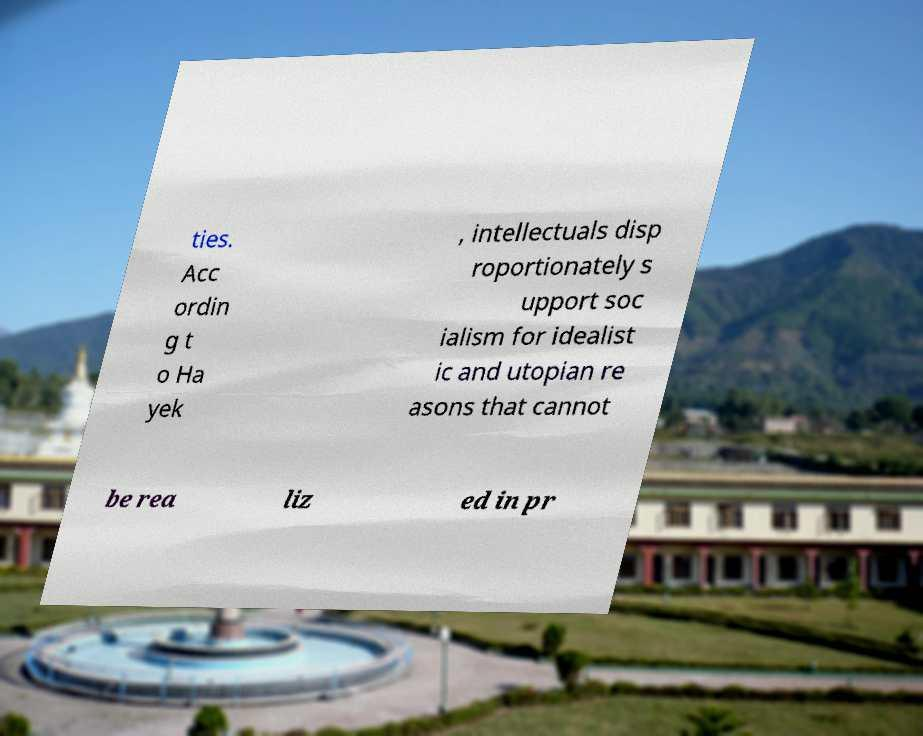Could you extract and type out the text from this image? ties. Acc ordin g t o Ha yek , intellectuals disp roportionately s upport soc ialism for idealist ic and utopian re asons that cannot be rea liz ed in pr 